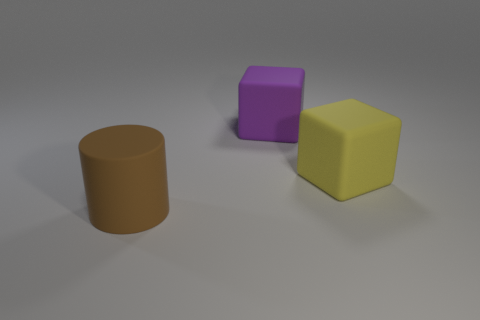What is the material of the big block on the left side of the yellow object?
Keep it short and to the point. Rubber. Is the number of large brown objects in front of the large matte cylinder less than the number of large brown rubber objects?
Your response must be concise. Yes. Is the purple object the same shape as the large brown matte object?
Offer a very short reply. No. Is there anything else that has the same shape as the purple rubber object?
Your response must be concise. Yes. Is there a big yellow object?
Offer a terse response. Yes. Is the shape of the big yellow object the same as the large matte thing on the left side of the purple rubber object?
Your answer should be compact. No. There is a thing on the right side of the big purple matte thing that is behind the big yellow cube; what is it made of?
Your answer should be compact. Rubber. What is the color of the matte cylinder?
Keep it short and to the point. Brown. There is a matte block behind the yellow rubber thing; is it the same color as the large matte object that is in front of the yellow cube?
Offer a terse response. No. There is a yellow matte object that is the same shape as the large purple rubber thing; what is its size?
Your answer should be very brief. Large. 